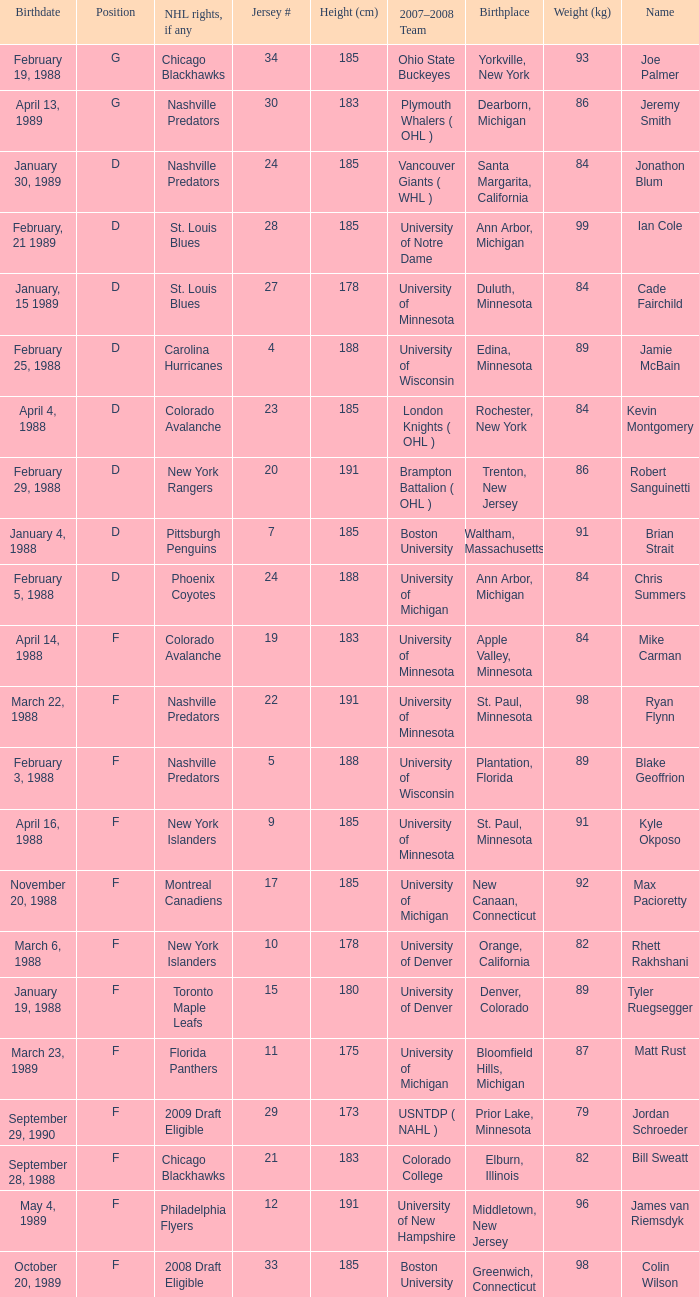Which Weight (kg) has a NHL rights, if any of phoenix coyotes? 1.0. 